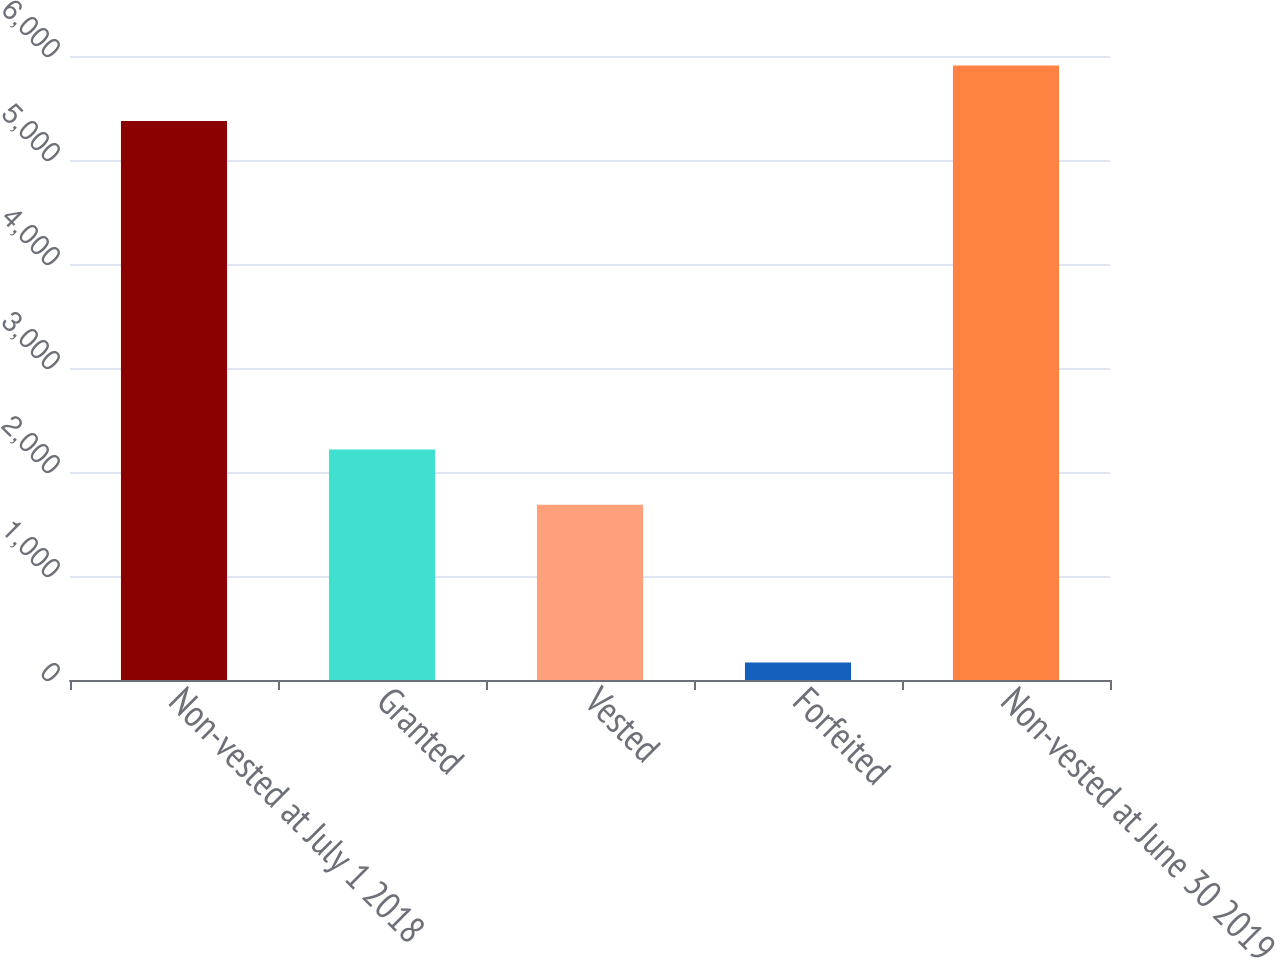<chart> <loc_0><loc_0><loc_500><loc_500><bar_chart><fcel>Non-vested at July 1 2018<fcel>Granted<fcel>Vested<fcel>Forfeited<fcel>Non-vested at June 30 2019<nl><fcel>5376<fcel>2217.5<fcel>1685<fcel>168<fcel>5908.5<nl></chart> 